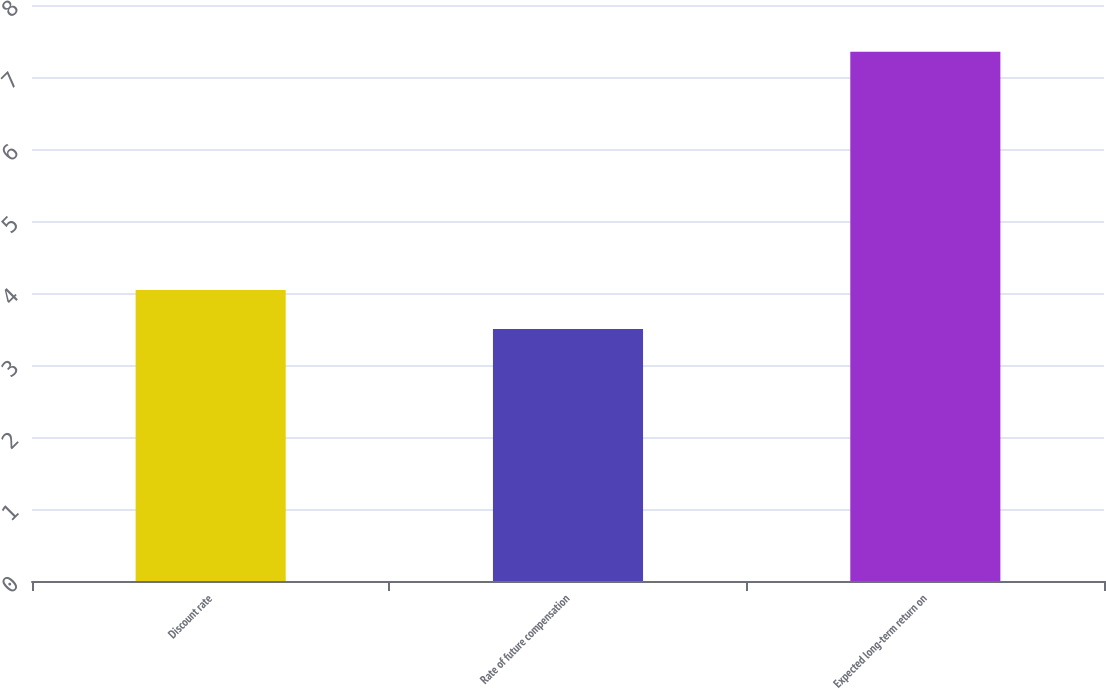Convert chart to OTSL. <chart><loc_0><loc_0><loc_500><loc_500><bar_chart><fcel>Discount rate<fcel>Rate of future compensation<fcel>Expected long-term return on<nl><fcel>4.04<fcel>3.5<fcel>7.35<nl></chart> 